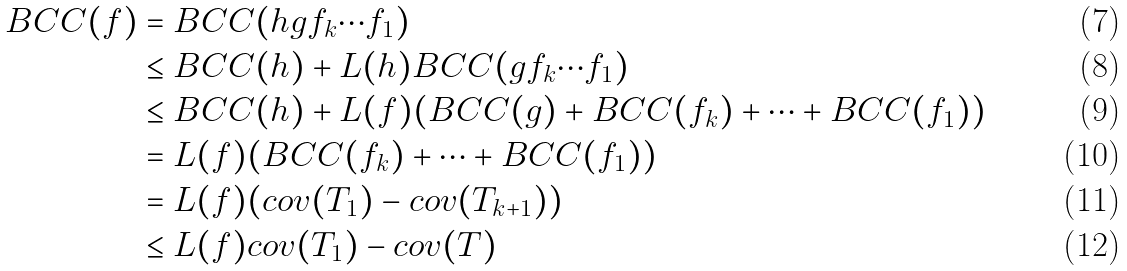<formula> <loc_0><loc_0><loc_500><loc_500>B C C ( f ) & = B C C ( h g f _ { k } \cdots f _ { 1 } ) \\ & \leq B C C ( h ) + L ( h ) B C C ( g f _ { k } \cdots f _ { 1 } ) \\ & \leq B C C ( h ) + L ( f ) ( B C C ( g ) + B C C ( f _ { k } ) + \cdots + B C C ( f _ { 1 } ) ) \\ & = L ( f ) ( B C C ( f _ { k } ) + \cdots + B C C ( f _ { 1 } ) ) \\ & = L ( f ) ( c o v ( T _ { 1 } ) - c o v ( T _ { k + 1 } ) ) \\ & \leq L ( f ) c o v ( T _ { 1 } ) - c o v ( T )</formula> 